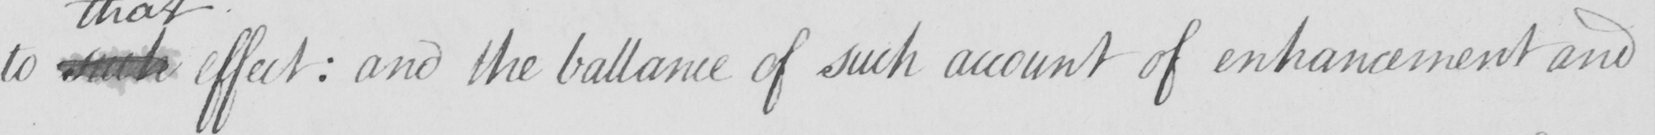Please provide the text content of this handwritten line. to such effect  :  and the ballance of such account of enhancement and 